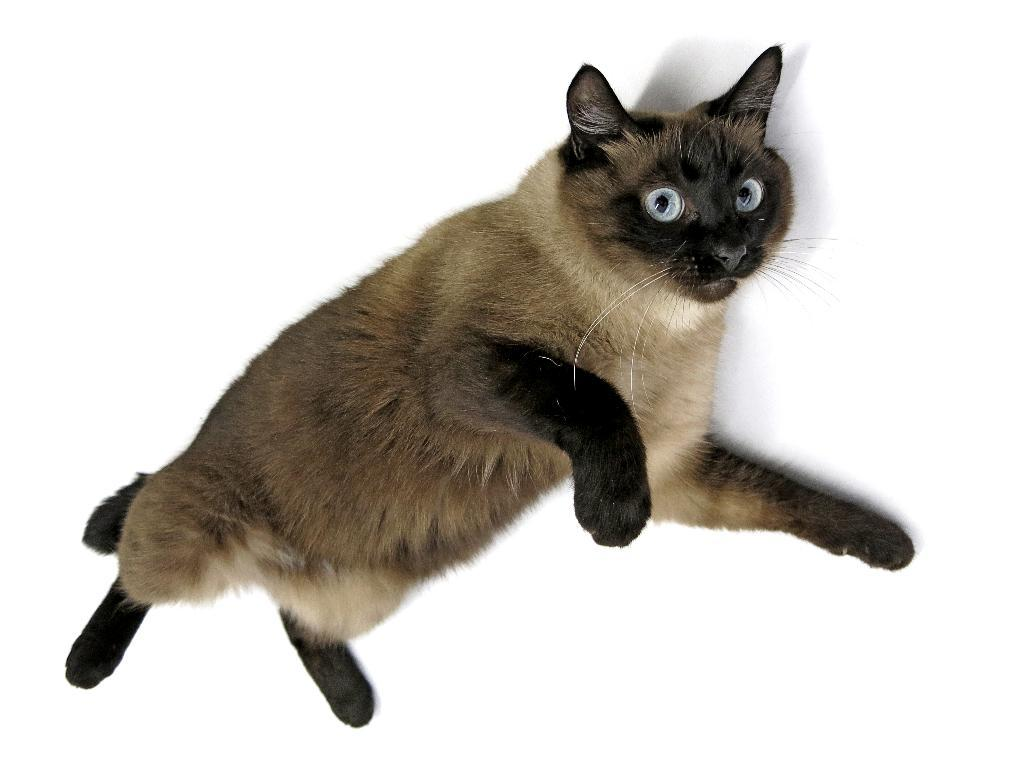What type of animal is in the image? There is a cat in the image. What color is the background of the cat? The background of the cat is white. How many ladybugs can be seen on the cat in the image? There are no ladybugs present in the image. 